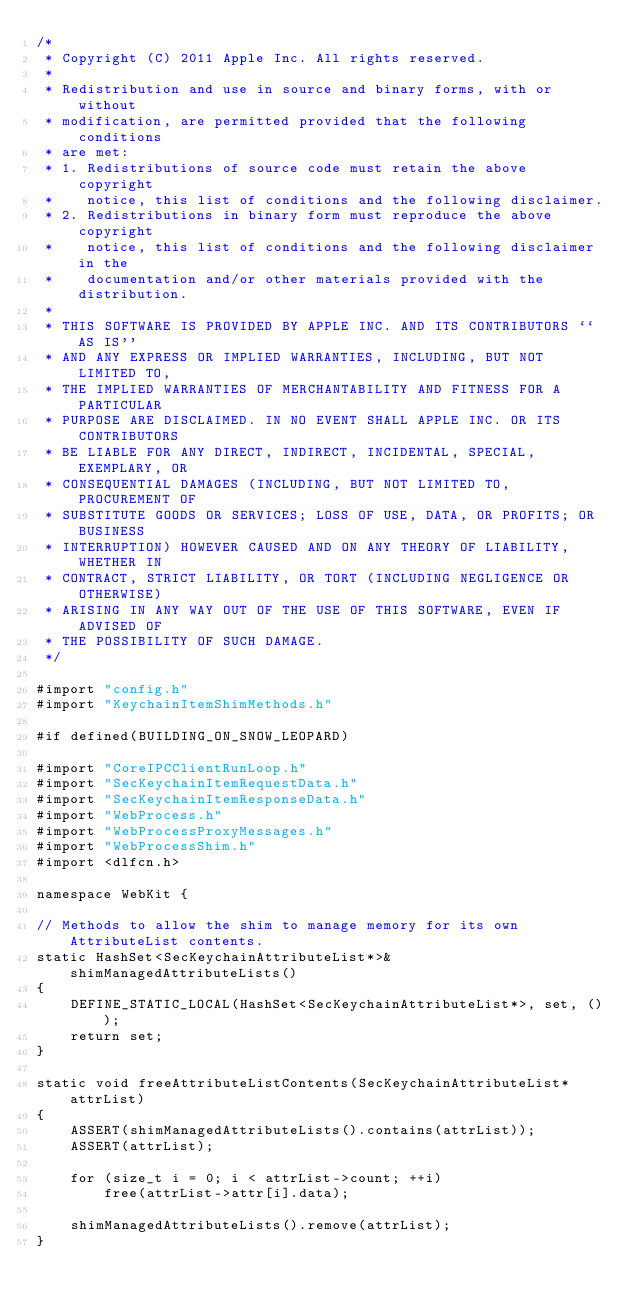<code> <loc_0><loc_0><loc_500><loc_500><_ObjectiveC_>/*
 * Copyright (C) 2011 Apple Inc. All rights reserved.
 *
 * Redistribution and use in source and binary forms, with or without
 * modification, are permitted provided that the following conditions
 * are met:
 * 1. Redistributions of source code must retain the above copyright
 *    notice, this list of conditions and the following disclaimer.
 * 2. Redistributions in binary form must reproduce the above copyright
 *    notice, this list of conditions and the following disclaimer in the
 *    documentation and/or other materials provided with the distribution.
 *
 * THIS SOFTWARE IS PROVIDED BY APPLE INC. AND ITS CONTRIBUTORS ``AS IS''
 * AND ANY EXPRESS OR IMPLIED WARRANTIES, INCLUDING, BUT NOT LIMITED TO,
 * THE IMPLIED WARRANTIES OF MERCHANTABILITY AND FITNESS FOR A PARTICULAR
 * PURPOSE ARE DISCLAIMED. IN NO EVENT SHALL APPLE INC. OR ITS CONTRIBUTORS
 * BE LIABLE FOR ANY DIRECT, INDIRECT, INCIDENTAL, SPECIAL, EXEMPLARY, OR
 * CONSEQUENTIAL DAMAGES (INCLUDING, BUT NOT LIMITED TO, PROCUREMENT OF
 * SUBSTITUTE GOODS OR SERVICES; LOSS OF USE, DATA, OR PROFITS; OR BUSINESS
 * INTERRUPTION) HOWEVER CAUSED AND ON ANY THEORY OF LIABILITY, WHETHER IN
 * CONTRACT, STRICT LIABILITY, OR TORT (INCLUDING NEGLIGENCE OR OTHERWISE)
 * ARISING IN ANY WAY OUT OF THE USE OF THIS SOFTWARE, EVEN IF ADVISED OF
 * THE POSSIBILITY OF SUCH DAMAGE.
 */

#import "config.h"
#import "KeychainItemShimMethods.h"

#if defined(BUILDING_ON_SNOW_LEOPARD)

#import "CoreIPCClientRunLoop.h"
#import "SecKeychainItemRequestData.h"
#import "SecKeychainItemResponseData.h"
#import "WebProcess.h"
#import "WebProcessProxyMessages.h"
#import "WebProcessShim.h"
#import <dlfcn.h>

namespace WebKit {

// Methods to allow the shim to manage memory for its own AttributeList contents.
static HashSet<SecKeychainAttributeList*>& shimManagedAttributeLists()
{
    DEFINE_STATIC_LOCAL(HashSet<SecKeychainAttributeList*>, set, ());
    return set;
}

static void freeAttributeListContents(SecKeychainAttributeList* attrList)
{
    ASSERT(shimManagedAttributeLists().contains(attrList));
    ASSERT(attrList);
    
    for (size_t i = 0; i < attrList->count; ++i)
        free(attrList->attr[i].data);

    shimManagedAttributeLists().remove(attrList);
}
</code> 